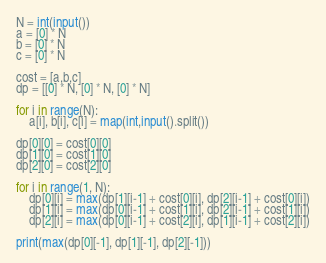<code> <loc_0><loc_0><loc_500><loc_500><_Python_>N = int(input())
a = [0] * N
b = [0] * N
c = [0] * N

cost = [a,b,c]
dp = [[0] * N, [0] * N, [0] * N]

for i in range(N):
    a[i], b[i], c[i] = map(int,input().split())

dp[0][0] = cost[0][0]
dp[1][0] = cost[1][0]
dp[2][0] = cost[2][0]

for i in range(1, N):
    dp[0][i] = max(dp[1][i-1] + cost[0][i], dp[2][i-1] + cost[0][i])
    dp[1][i] = max(dp[0][i-1] + cost[1][i], dp[2][i-1] + cost[1][i])
    dp[2][i] = max(dp[0][i-1] + cost[2][i], dp[1][i-1] + cost[2][i])

print(max(dp[0][-1], dp[1][-1], dp[2][-1]))</code> 